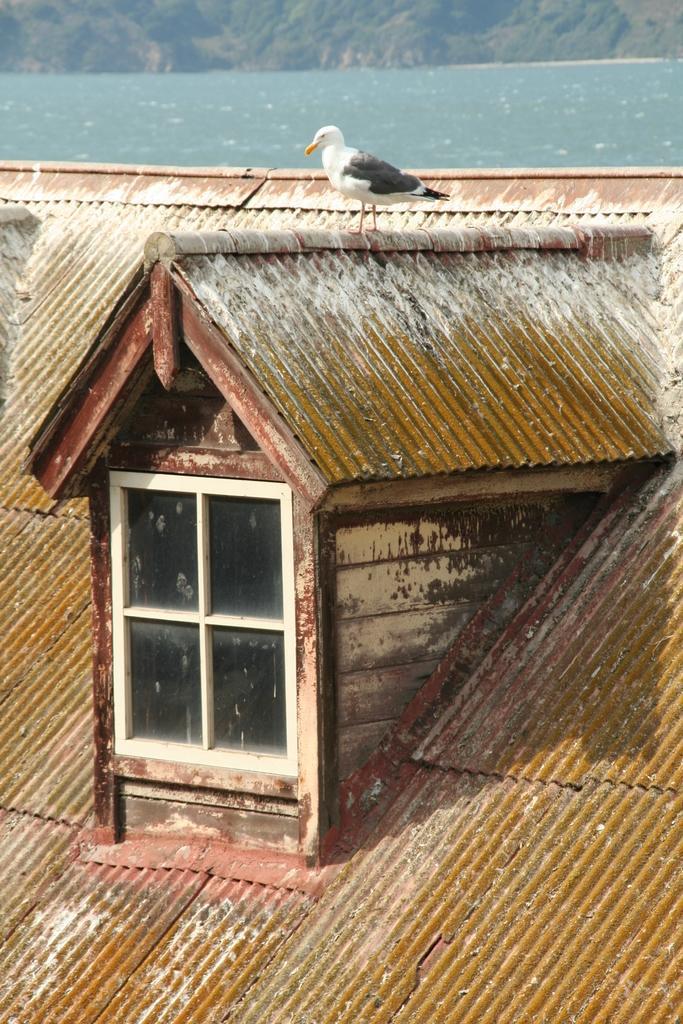In one or two sentences, can you explain what this image depicts? In the center of the image there is a bird, window and shed. In the background we can see water and hill. 